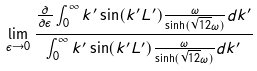Convert formula to latex. <formula><loc_0><loc_0><loc_500><loc_500>\lim _ { \epsilon \to 0 } \frac { \frac { \partial } { \partial \epsilon } \int _ { 0 } ^ { \infty } k ^ { \prime } \sin ( k ^ { \prime } L ^ { \prime } ) \frac { \omega } { \sinh ( \sqrt { 1 2 } \omega ) } d k ^ { \prime } } { \int _ { 0 } ^ { \infty } k ^ { \prime } \sin ( k ^ { \prime } L ^ { \prime } ) \frac { \omega } { \sinh ( \sqrt { 1 2 } \omega ) } d k ^ { \prime } }</formula> 